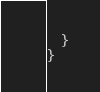Convert code to text. <code><loc_0><loc_0><loc_500><loc_500><_TypeScript_>  }
}
</code> 